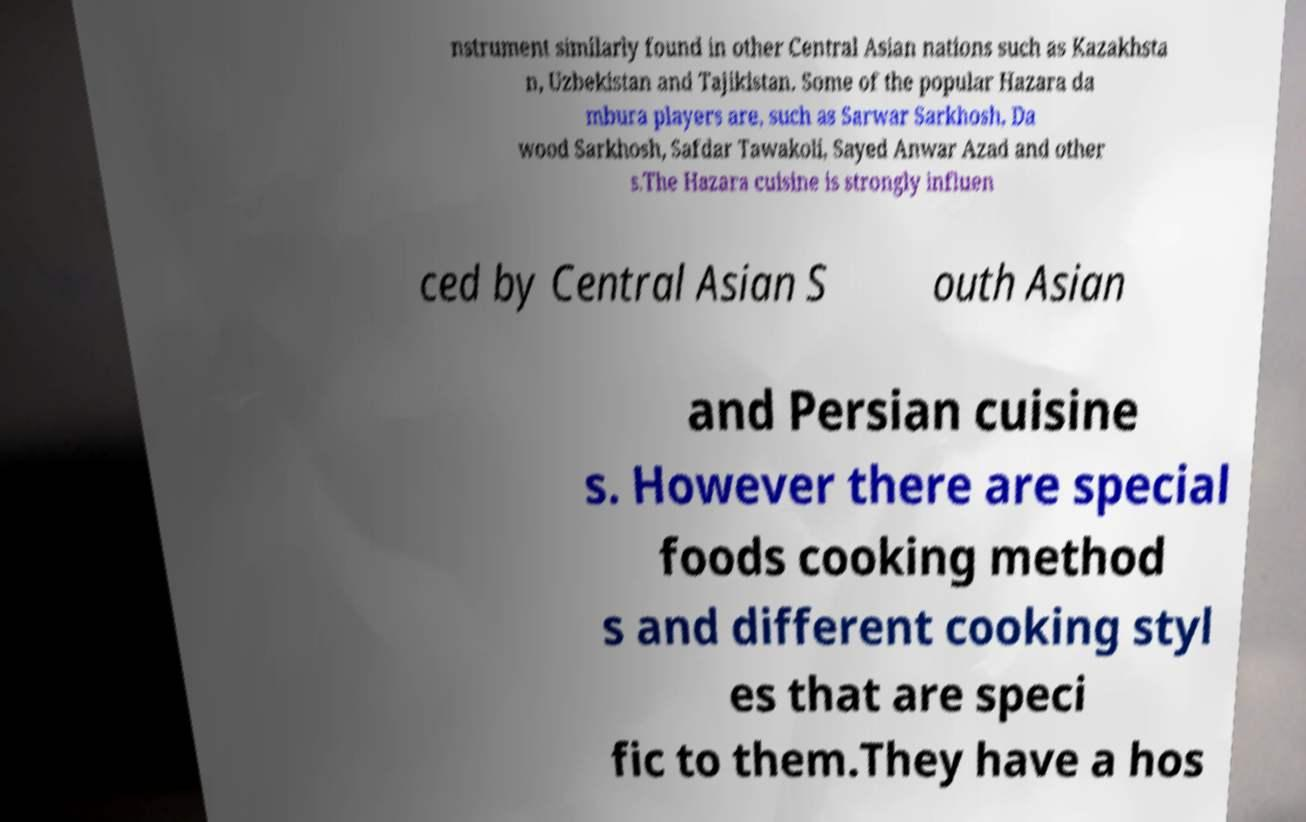I need the written content from this picture converted into text. Can you do that? nstrument similarly found in other Central Asian nations such as Kazakhsta n, Uzbekistan and Tajikistan. Some of the popular Hazara da mbura players are, such as Sarwar Sarkhosh, Da wood Sarkhosh, Safdar Tawakoli, Sayed Anwar Azad and other s.The Hazara cuisine is strongly influen ced by Central Asian S outh Asian and Persian cuisine s. However there are special foods cooking method s and different cooking styl es that are speci fic to them.They have a hos 